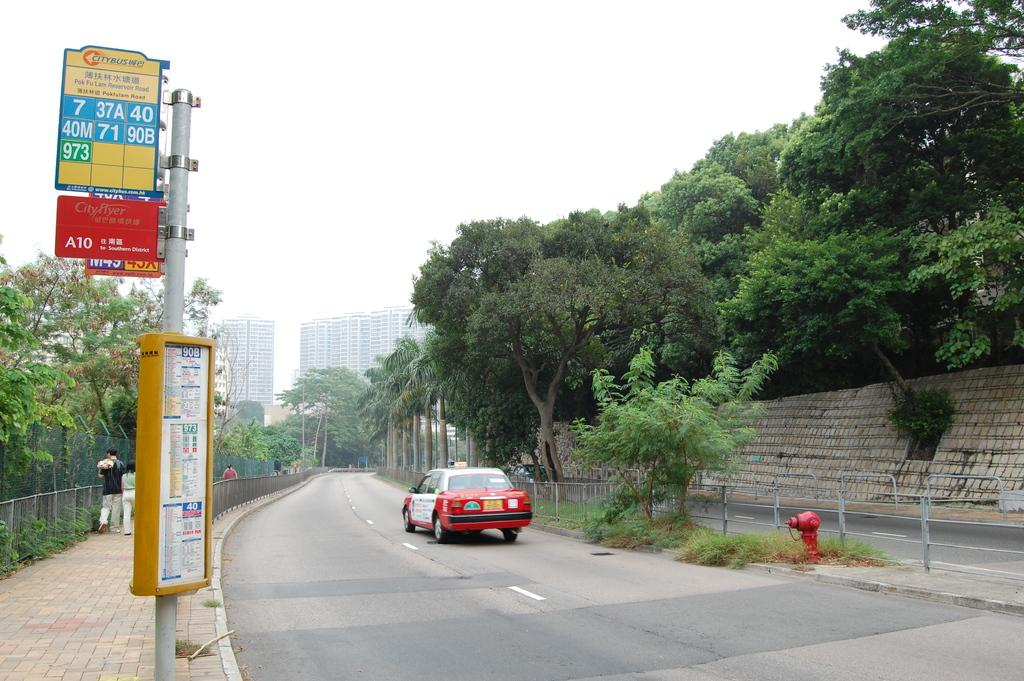<image>
Create a compact narrative representing the image presented. A quiet road has a Citybus stop and one lone cab driving down the street. 